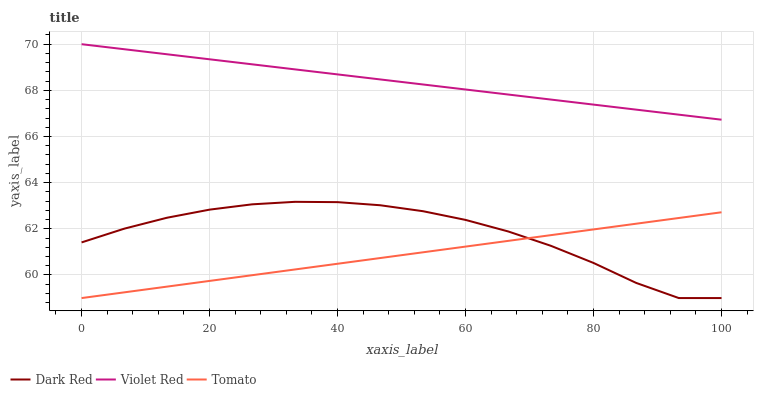Does Tomato have the minimum area under the curve?
Answer yes or no. Yes. Does Violet Red have the maximum area under the curve?
Answer yes or no. Yes. Does Dark Red have the minimum area under the curve?
Answer yes or no. No. Does Dark Red have the maximum area under the curve?
Answer yes or no. No. Is Tomato the smoothest?
Answer yes or no. Yes. Is Dark Red the roughest?
Answer yes or no. Yes. Is Violet Red the smoothest?
Answer yes or no. No. Is Violet Red the roughest?
Answer yes or no. No. Does Tomato have the lowest value?
Answer yes or no. Yes. Does Violet Red have the lowest value?
Answer yes or no. No. Does Violet Red have the highest value?
Answer yes or no. Yes. Does Dark Red have the highest value?
Answer yes or no. No. Is Dark Red less than Violet Red?
Answer yes or no. Yes. Is Violet Red greater than Tomato?
Answer yes or no. Yes. Does Tomato intersect Dark Red?
Answer yes or no. Yes. Is Tomato less than Dark Red?
Answer yes or no. No. Is Tomato greater than Dark Red?
Answer yes or no. No. Does Dark Red intersect Violet Red?
Answer yes or no. No. 